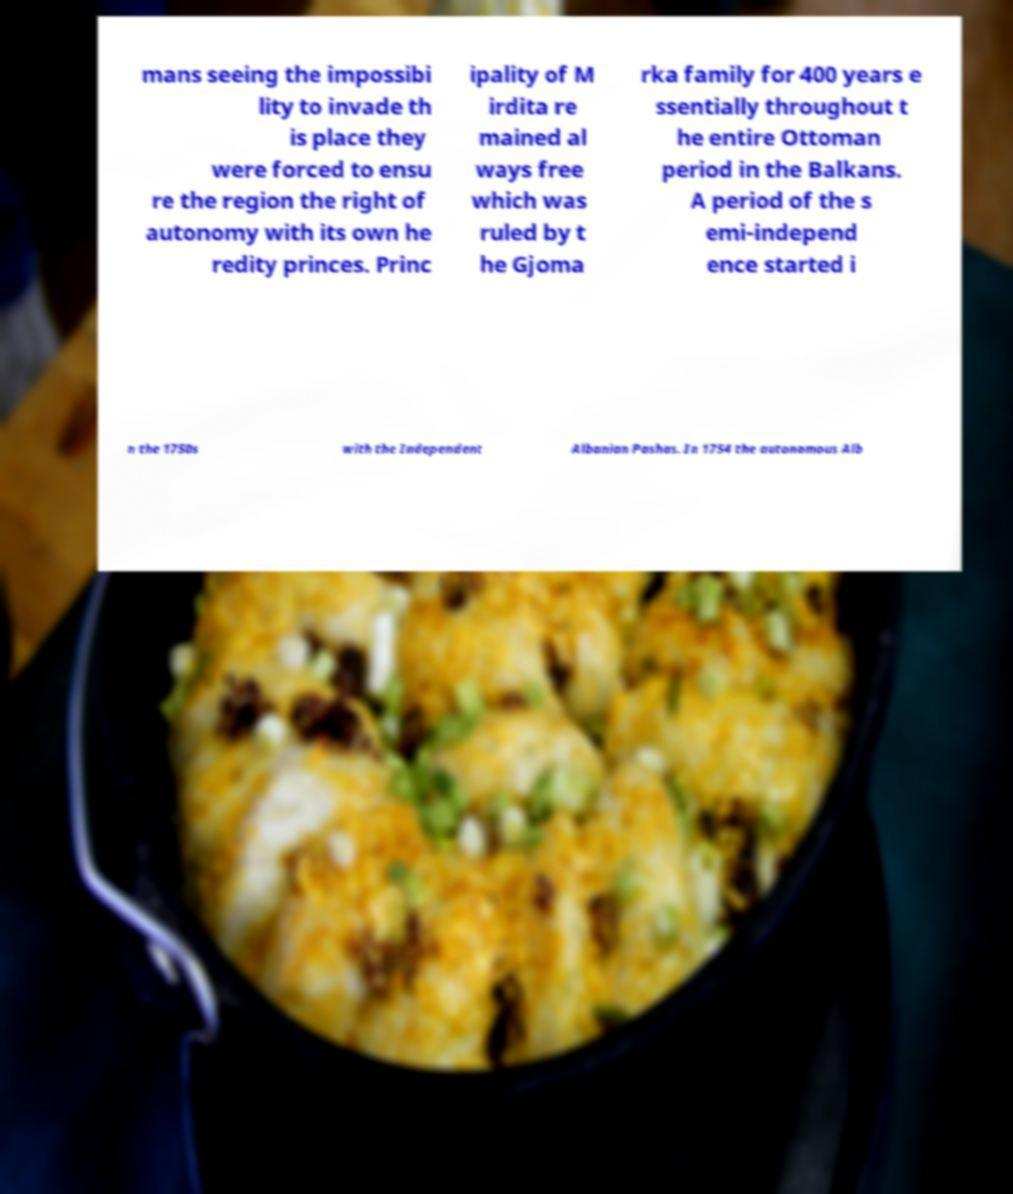Please identify and transcribe the text found in this image. mans seeing the impossibi lity to invade th is place they were forced to ensu re the region the right of autonomy with its own he redity princes. Princ ipality of M irdita re mained al ways free which was ruled by t he Gjoma rka family for 400 years e ssentially throughout t he entire Ottoman period in the Balkans. A period of the s emi-independ ence started i n the 1750s with the Independent Albanian Pashas. In 1754 the autonomous Alb 